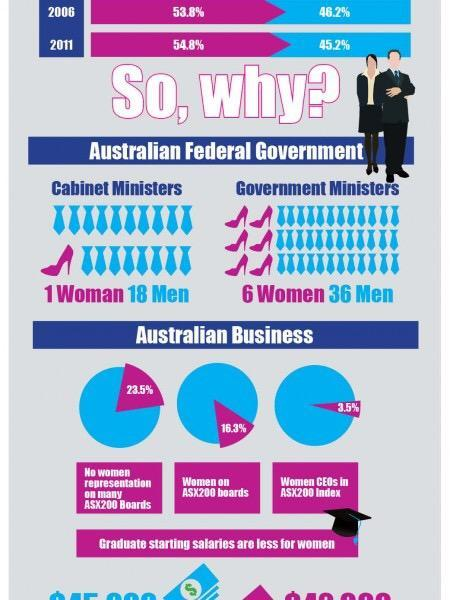Which gender of Government Ministers dominate in the Australian Federal Government?
Answer the question with a short phrase. Male Which gender of Government Ministers least dominate in the Australian Federal Government? Female Which gender of CEOs most dominate in the Australian Business Male Which gender of Cabinet Ministers least dominate in the Australian Federal Government? Female Which gender of CEOs least dominate in the Australian Business Female Which gender of Cabinet Ministers dominate in the Australian Federal Government? Male 